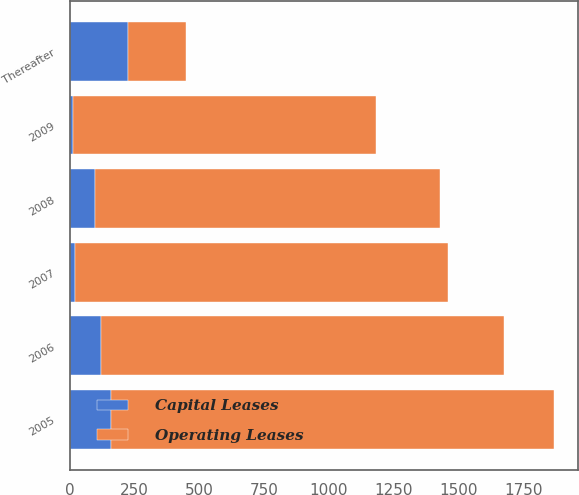Convert chart. <chart><loc_0><loc_0><loc_500><loc_500><stacked_bar_chart><ecel><fcel>2005<fcel>2006<fcel>2007<fcel>2008<fcel>2009<fcel>Thereafter<nl><fcel>Capital Leases<fcel>160<fcel>122<fcel>22<fcel>99<fcel>11<fcel>225<nl><fcel>Operating Leases<fcel>1707<fcel>1555<fcel>1436<fcel>1329<fcel>1169<fcel>225<nl></chart> 